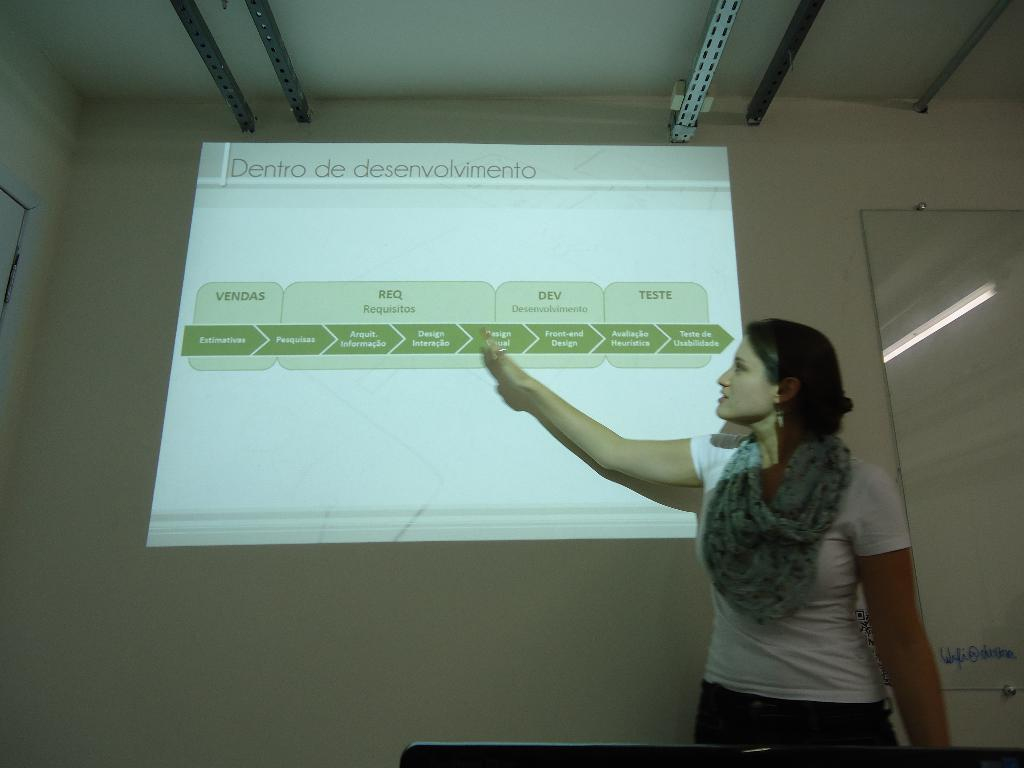<image>
Summarize the visual content of the image. A woman pointing to a display that says Dento de desenvolvimento on it. 